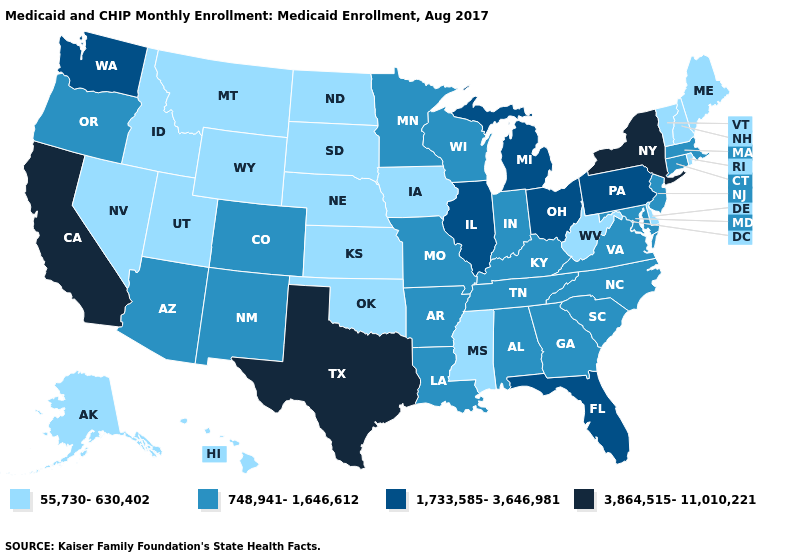What is the value of South Dakota?
Write a very short answer. 55,730-630,402. What is the value of North Carolina?
Answer briefly. 748,941-1,646,612. Among the states that border Minnesota , which have the lowest value?
Keep it brief. Iowa, North Dakota, South Dakota. What is the lowest value in the USA?
Answer briefly. 55,730-630,402. Does the map have missing data?
Answer briefly. No. Does Montana have the highest value in the USA?
Be succinct. No. What is the value of Kansas?
Give a very brief answer. 55,730-630,402. Name the states that have a value in the range 748,941-1,646,612?
Answer briefly. Alabama, Arizona, Arkansas, Colorado, Connecticut, Georgia, Indiana, Kentucky, Louisiana, Maryland, Massachusetts, Minnesota, Missouri, New Jersey, New Mexico, North Carolina, Oregon, South Carolina, Tennessee, Virginia, Wisconsin. Does California have the highest value in the USA?
Be succinct. Yes. Name the states that have a value in the range 55,730-630,402?
Be succinct. Alaska, Delaware, Hawaii, Idaho, Iowa, Kansas, Maine, Mississippi, Montana, Nebraska, Nevada, New Hampshire, North Dakota, Oklahoma, Rhode Island, South Dakota, Utah, Vermont, West Virginia, Wyoming. Does Alabama have the lowest value in the USA?
Short answer required. No. What is the highest value in the USA?
Write a very short answer. 3,864,515-11,010,221. What is the lowest value in the South?
Answer briefly. 55,730-630,402. Which states have the lowest value in the South?
Concise answer only. Delaware, Mississippi, Oklahoma, West Virginia. 